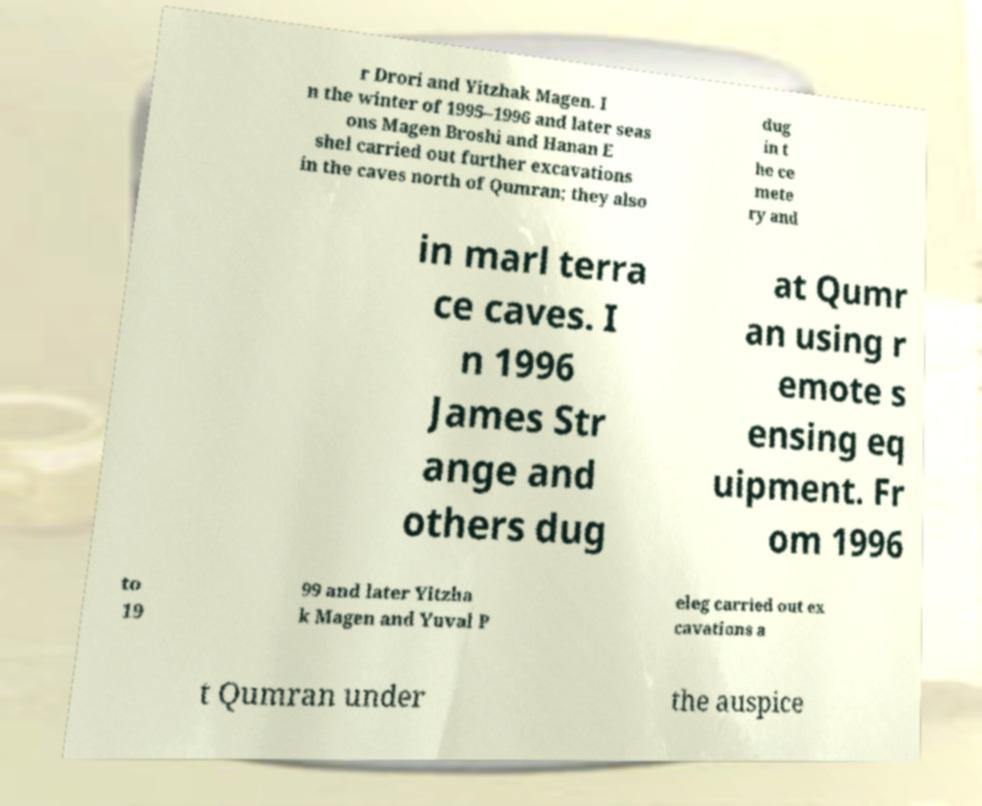Can you accurately transcribe the text from the provided image for me? r Drori and Yitzhak Magen. I n the winter of 1995–1996 and later seas ons Magen Broshi and Hanan E shel carried out further excavations in the caves north of Qumran; they also dug in t he ce mete ry and in marl terra ce caves. I n 1996 James Str ange and others dug at Qumr an using r emote s ensing eq uipment. Fr om 1996 to 19 99 and later Yitzha k Magen and Yuval P eleg carried out ex cavations a t Qumran under the auspice 